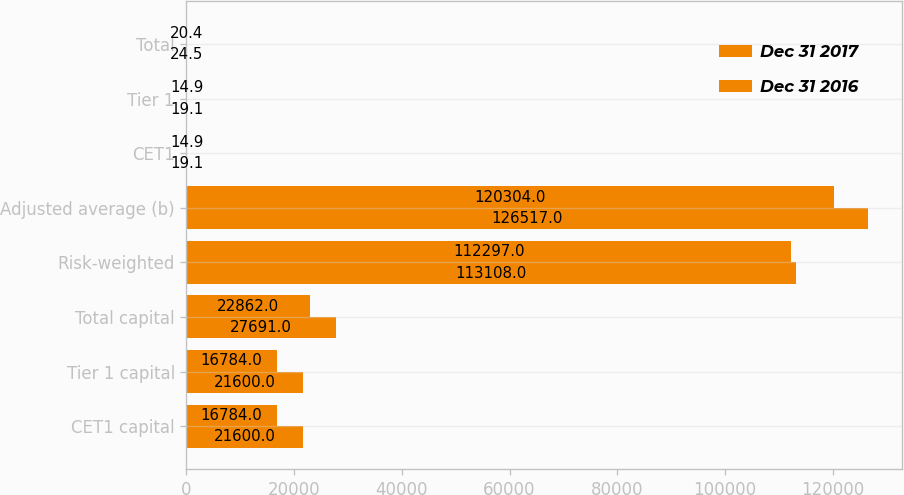Convert chart. <chart><loc_0><loc_0><loc_500><loc_500><stacked_bar_chart><ecel><fcel>CET1 capital<fcel>Tier 1 capital<fcel>Total capital<fcel>Risk-weighted<fcel>Adjusted average (b)<fcel>CET1<fcel>Tier 1<fcel>Total<nl><fcel>Dec 31 2017<fcel>21600<fcel>21600<fcel>27691<fcel>113108<fcel>126517<fcel>19.1<fcel>19.1<fcel>24.5<nl><fcel>Dec 31 2016<fcel>16784<fcel>16784<fcel>22862<fcel>112297<fcel>120304<fcel>14.9<fcel>14.9<fcel>20.4<nl></chart> 